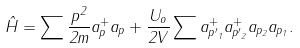Convert formula to latex. <formula><loc_0><loc_0><loc_500><loc_500>\hat { H } = \sum \frac { { p } ^ { 2 } } { 2 m } a _ { p } ^ { + } a _ { p } + \frac { U _ { o } } { 2 V } \sum a _ { { p ^ { \prime } } _ { 1 } } ^ { + } a _ { { p ^ { \prime } } _ { 2 } } ^ { + } a _ { p _ { 2 } } a _ { p _ { 1 } } .</formula> 